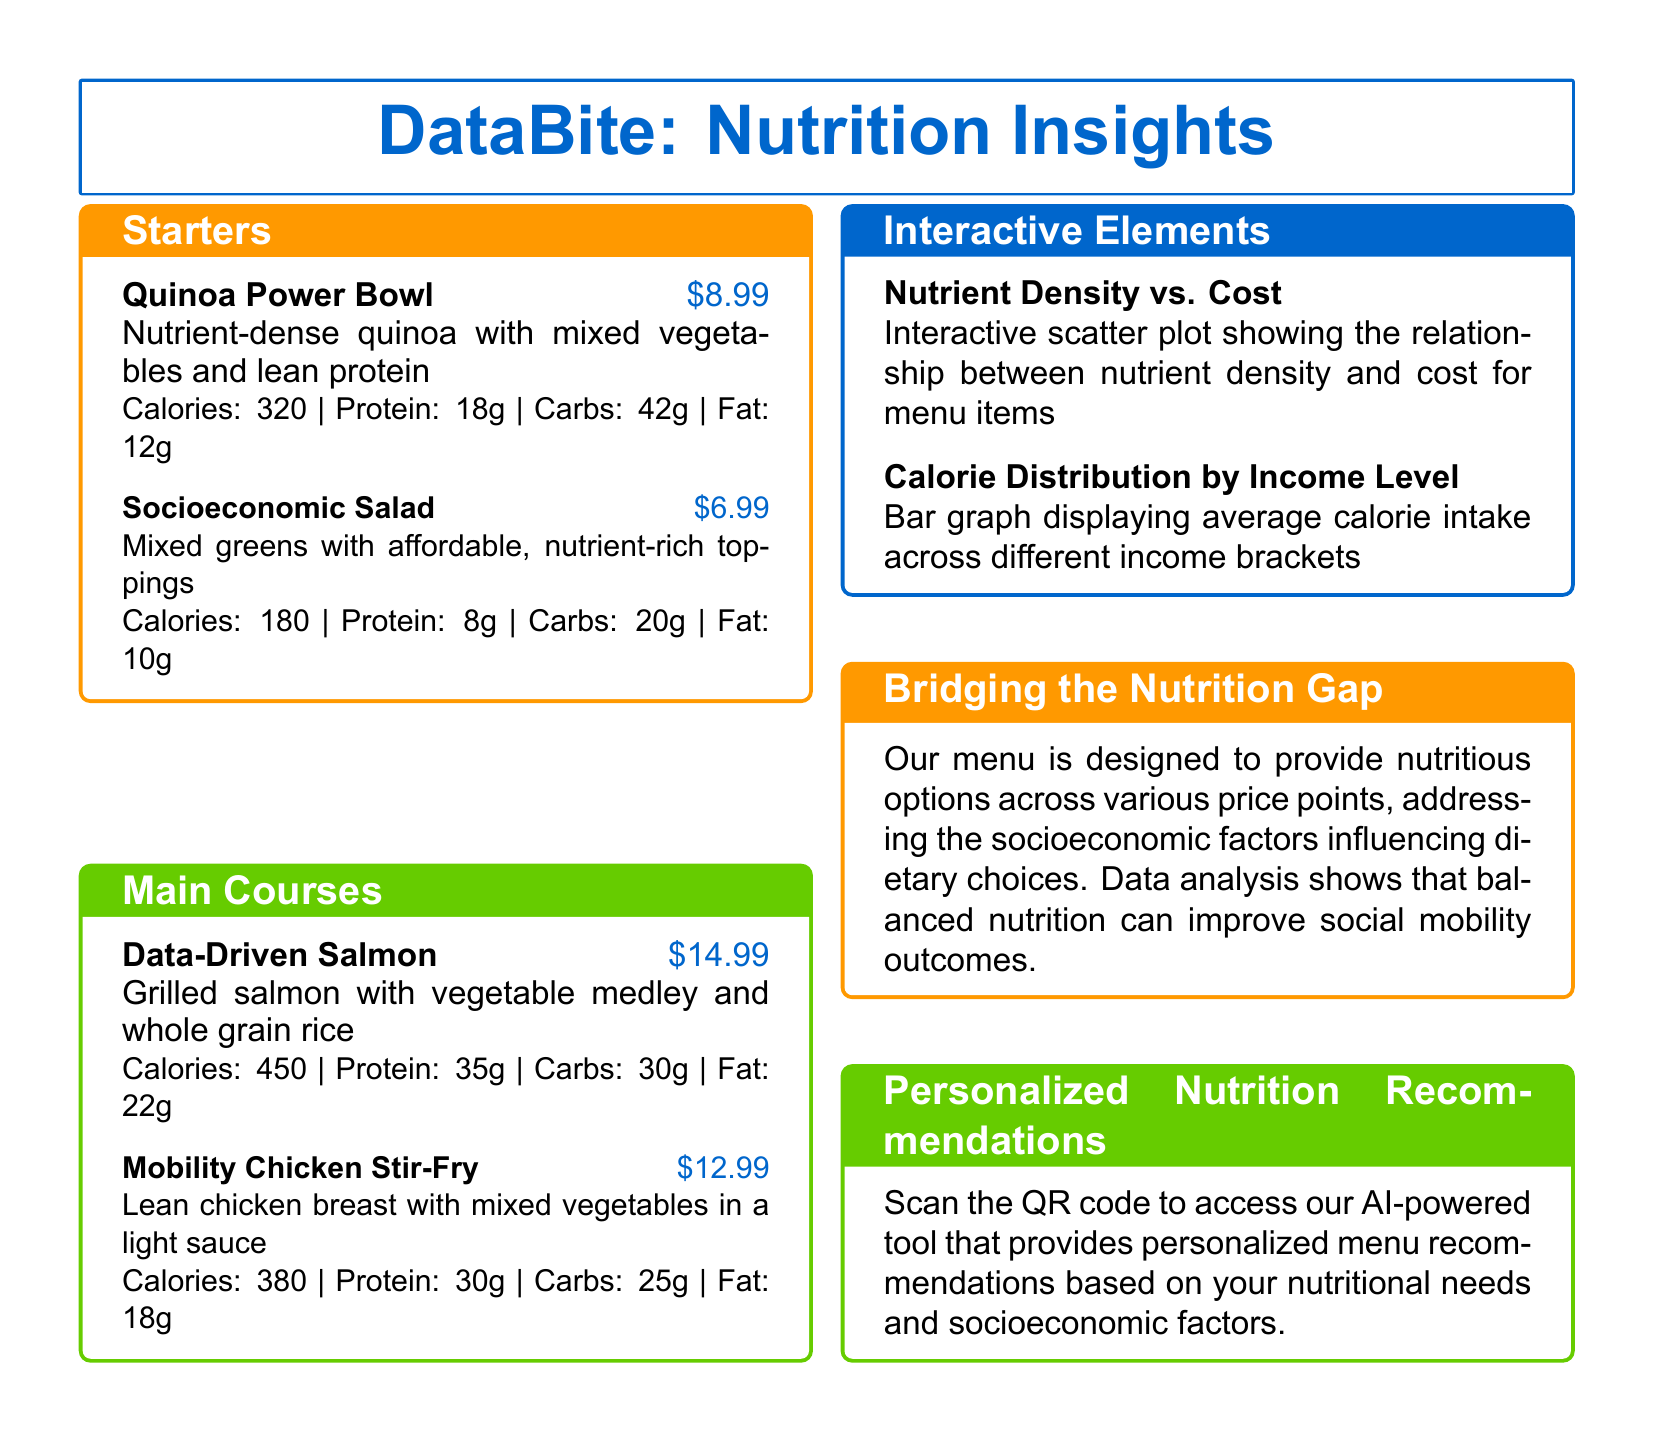What is the price of the Quinoa Power Bowl? The price of the Quinoa Power Bowl is listed in the document.
Answer: $8.99 How many grams of protein does the Socioeconomic Salad have? The nutritional information for the Socioeconomic Salad states its protein content.
Answer: 8g What is the calorie content of the Data-Driven Salmon? The calorie content for the Data-Driven Salmon is provided in the menu description.
Answer: 450 Which menu item has the lowest calorie count? By comparing the calorie counts listed for each item, we can determine which has the lowest.
Answer: Socioeconomic Salad What does the Interactive Elements section include? The section titled "Interactive Elements" includes specific visual data representations described in the document.
Answer: Nutrient Density vs. Cost and Calorie Distribution by Income Level How does the restaurant address socioeconomic factors? The document mentions how the menu aims to provide nutritious options influenced by socioeconomic factors.
Answer: By providing nutritious options across various price points What is suggested to access personalized nutrition recommendations? The document includes a method to access the AI-powered tool for personalized recommendations.
Answer: Scan the QR code What type of data visualization shows average calorie intake? The menu describes a specific visual representation that communicates calorie intake by income level.
Answer: Bar graph What is the key theme highlighted in the "Bridging the Nutrition Gap" section? The section emphasizes a significant aspect related to nutrition and socioeconomic implications.
Answer: Improving social mobility outcomes 